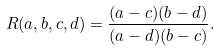<formula> <loc_0><loc_0><loc_500><loc_500>R ( a , b , c , d ) = \frac { ( a - c ) ( b - d ) } { ( a - d ) ( b - c ) } .</formula> 